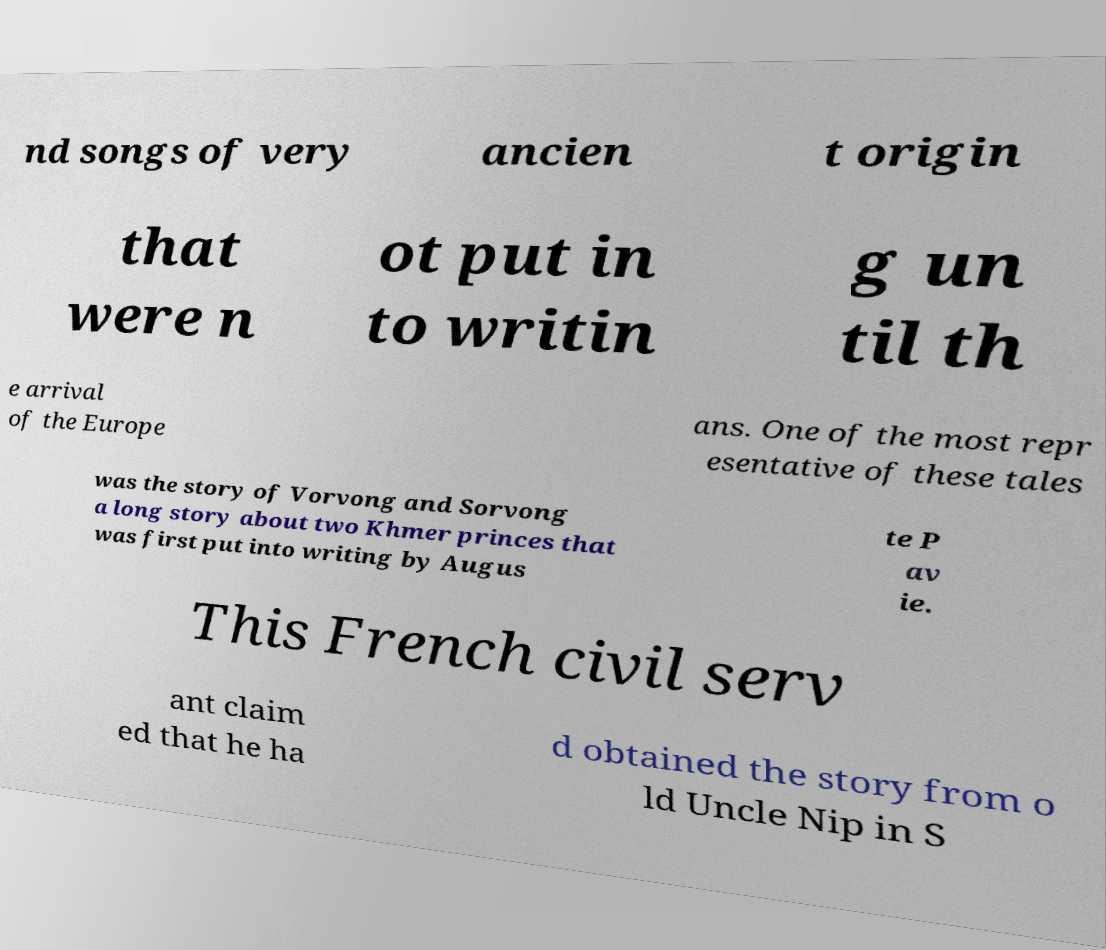Please read and relay the text visible in this image. What does it say? nd songs of very ancien t origin that were n ot put in to writin g un til th e arrival of the Europe ans. One of the most repr esentative of these tales was the story of Vorvong and Sorvong a long story about two Khmer princes that was first put into writing by Augus te P av ie. This French civil serv ant claim ed that he ha d obtained the story from o ld Uncle Nip in S 